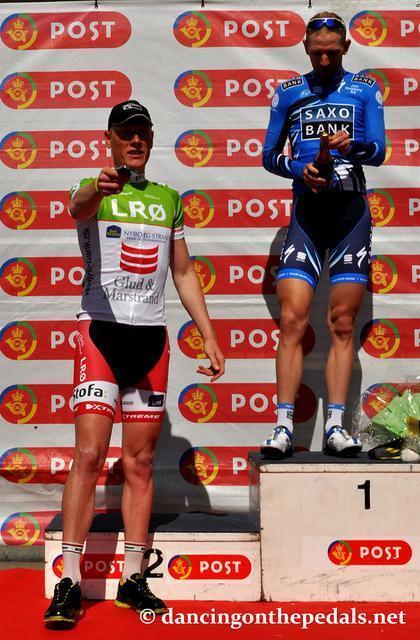How many people are pictured in the award's ceremony?
Give a very brief answer. 2. How many people are there?
Give a very brief answer. 2. 